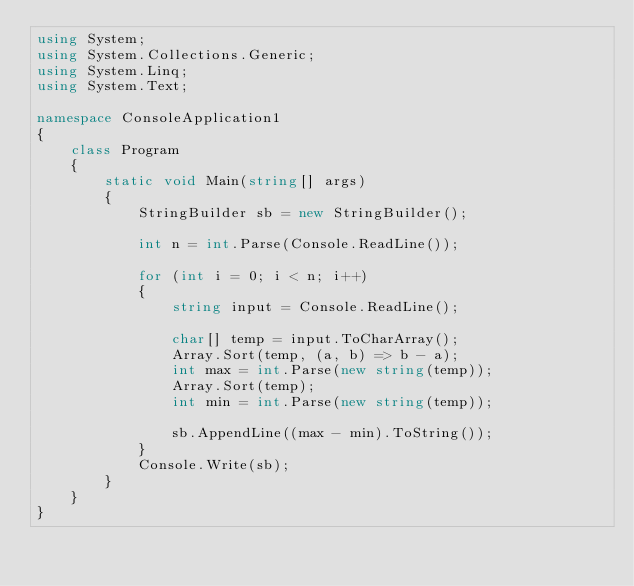Convert code to text. <code><loc_0><loc_0><loc_500><loc_500><_C#_>using System;
using System.Collections.Generic;
using System.Linq;
using System.Text;

namespace ConsoleApplication1
{
    class Program
    {
        static void Main(string[] args)
        {
            StringBuilder sb = new StringBuilder();

            int n = int.Parse(Console.ReadLine());

            for (int i = 0; i < n; i++)
            {
                string input = Console.ReadLine();

                char[] temp = input.ToCharArray();
                Array.Sort(temp, (a, b) => b - a);
                int max = int.Parse(new string(temp));
                Array.Sort(temp);
                int min = int.Parse(new string(temp));

                sb.AppendLine((max - min).ToString());
            }
            Console.Write(sb);
        }
    }
}</code> 